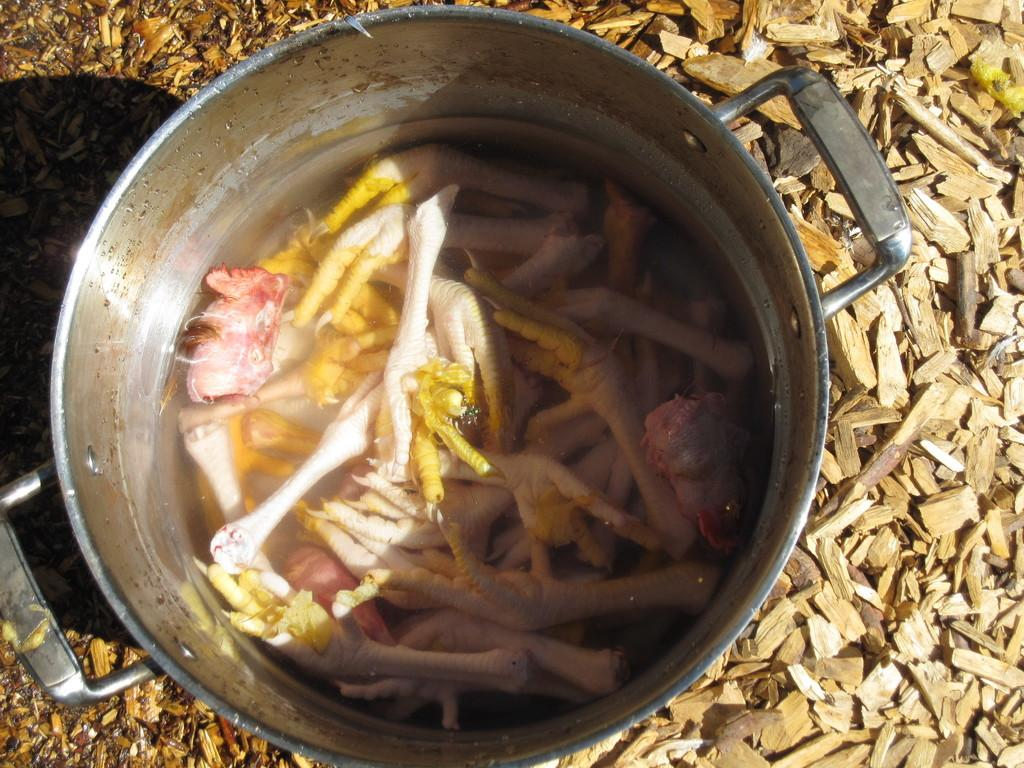What type of food is in the bowl in the image? There is meat in a bowl in the image. Where is the bowl located in the image? The bowl is on the ground. What can be seen in the background of the image? There are wooden sticks visible in the background of the image. What type of bread is being stored in the quiver in the image? There is no quiver or bread present in the image. 